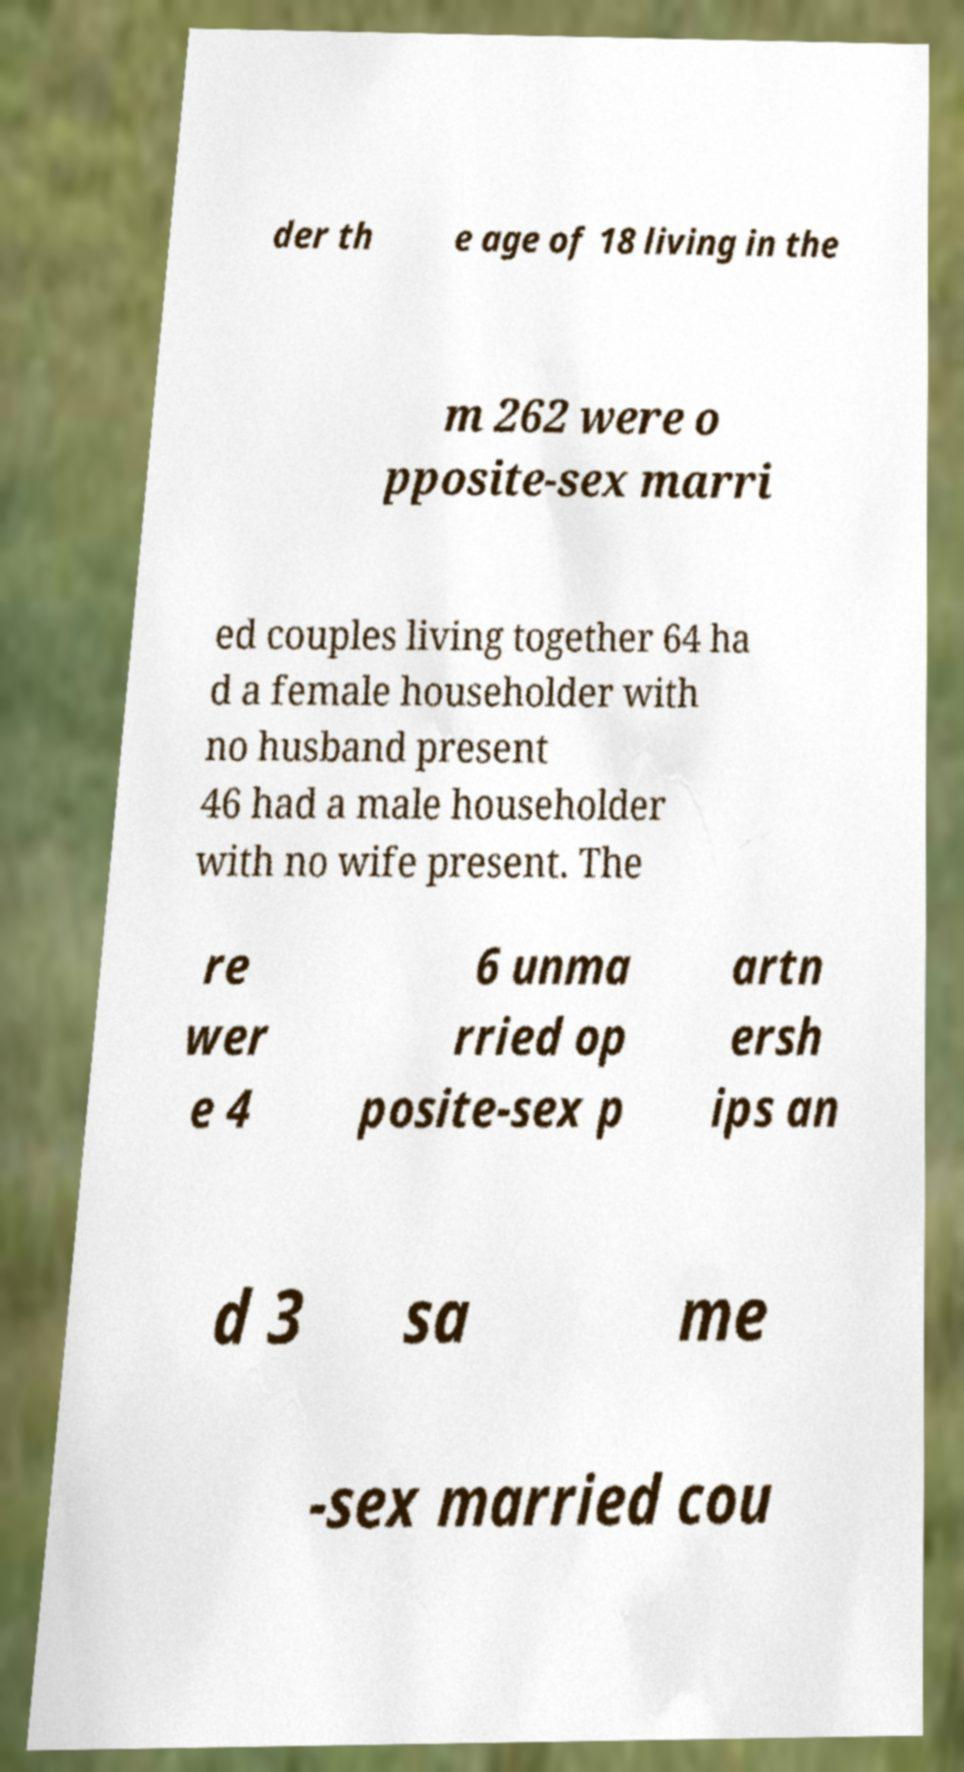Could you extract and type out the text from this image? der th e age of 18 living in the m 262 were o pposite-sex marri ed couples living together 64 ha d a female householder with no husband present 46 had a male householder with no wife present. The re wer e 4 6 unma rried op posite-sex p artn ersh ips an d 3 sa me -sex married cou 